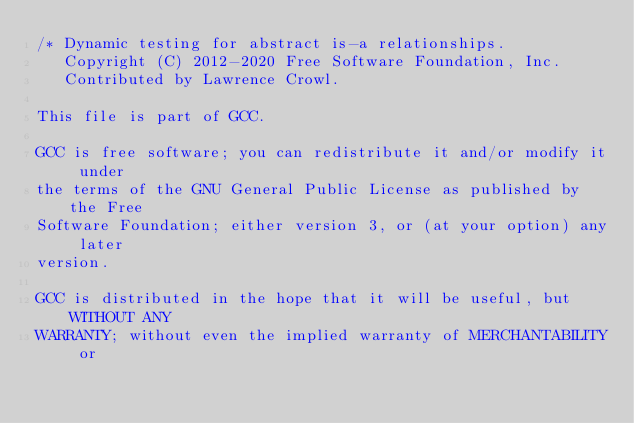Convert code to text. <code><loc_0><loc_0><loc_500><loc_500><_C_>/* Dynamic testing for abstract is-a relationships.
   Copyright (C) 2012-2020 Free Software Foundation, Inc.
   Contributed by Lawrence Crowl.

This file is part of GCC.

GCC is free software; you can redistribute it and/or modify it under
the terms of the GNU General Public License as published by the Free
Software Foundation; either version 3, or (at your option) any later
version.

GCC is distributed in the hope that it will be useful, but WITHOUT ANY
WARRANTY; without even the implied warranty of MERCHANTABILITY or</code> 